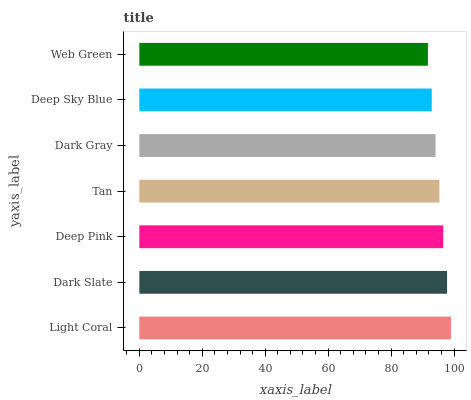Is Web Green the minimum?
Answer yes or no. Yes. Is Light Coral the maximum?
Answer yes or no. Yes. Is Dark Slate the minimum?
Answer yes or no. No. Is Dark Slate the maximum?
Answer yes or no. No. Is Light Coral greater than Dark Slate?
Answer yes or no. Yes. Is Dark Slate less than Light Coral?
Answer yes or no. Yes. Is Dark Slate greater than Light Coral?
Answer yes or no. No. Is Light Coral less than Dark Slate?
Answer yes or no. No. Is Tan the high median?
Answer yes or no. Yes. Is Tan the low median?
Answer yes or no. Yes. Is Dark Slate the high median?
Answer yes or no. No. Is Light Coral the low median?
Answer yes or no. No. 